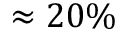<formula> <loc_0><loc_0><loc_500><loc_500>\approx 2 0 \%</formula> 